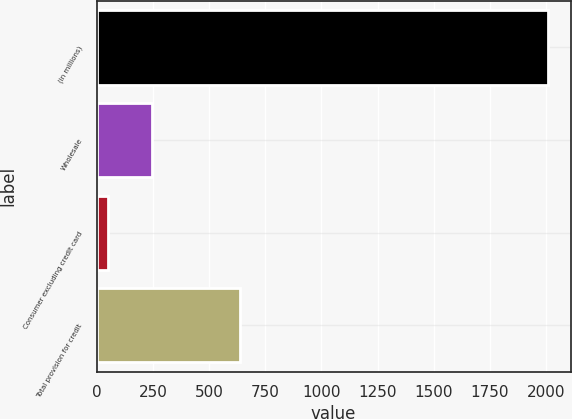Convert chart to OTSL. <chart><loc_0><loc_0><loc_500><loc_500><bar_chart><fcel>(in millions)<fcel>Wholesale<fcel>Consumer excluding credit card<fcel>Total provision for credit<nl><fcel>2008<fcel>244.9<fcel>49<fcel>636.7<nl></chart> 